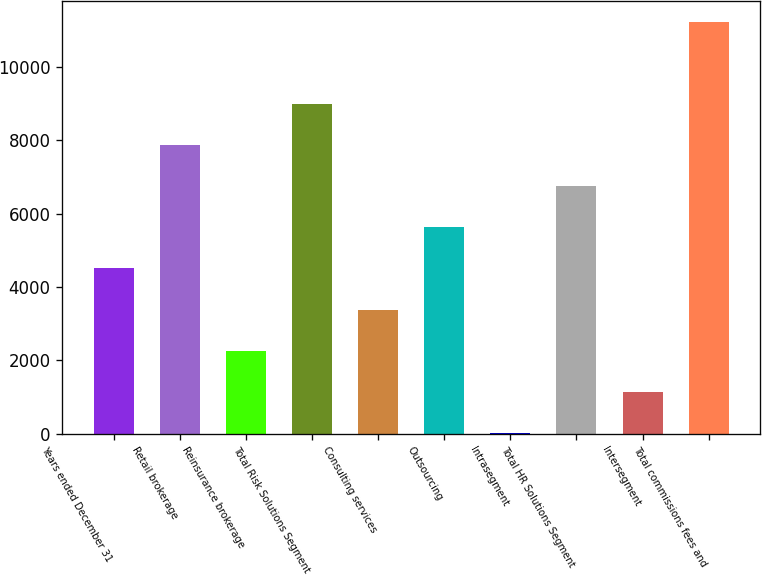Convert chart to OTSL. <chart><loc_0><loc_0><loc_500><loc_500><bar_chart><fcel>Years ended December 31<fcel>Retail brokerage<fcel>Reinsurance brokerage<fcel>Total Risk Solutions Segment<fcel>Consulting services<fcel>Outsourcing<fcel>Intrasegment<fcel>Total HR Solutions Segment<fcel>Intersegment<fcel>Total commissions fees and<nl><fcel>4507.8<fcel>7871.4<fcel>2265.4<fcel>8992.6<fcel>3386.6<fcel>5629<fcel>23<fcel>6750.2<fcel>1144.2<fcel>11235<nl></chart> 